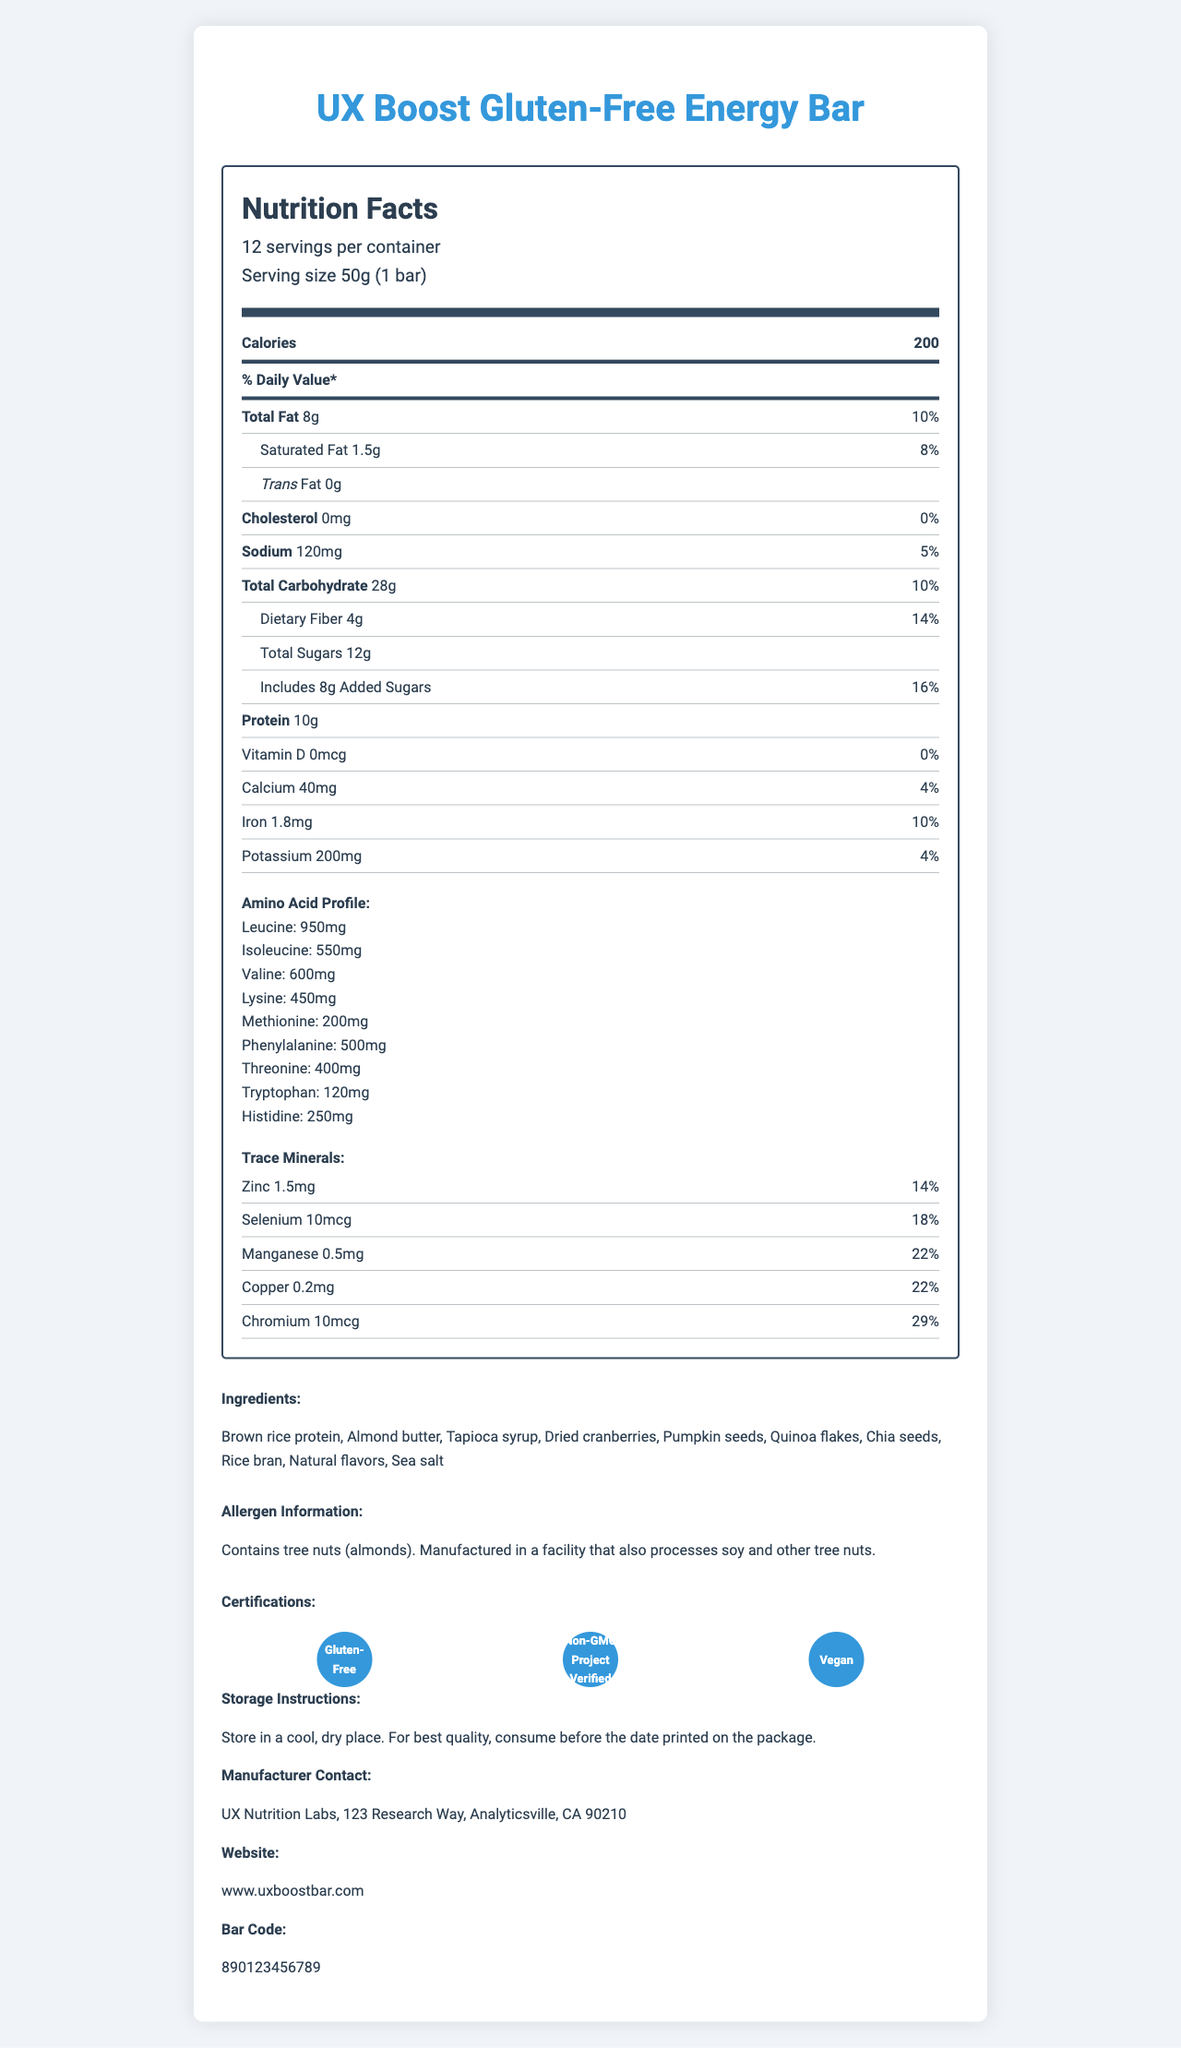what is the serving size for the "UX Boost Gluten-Free Energy Bar"? The serving size is stated as "50g (1 bar)" in the nutrition facts section.
Answer: 50g (1 bar) what is the total amount of protein in one serving? The nutrition label lists the protein content as "10g".
Answer: 10g which amino acid has the highest amount in the profile? A. Leucine B. Isoleucine C. Valine D. Lysine The amino acid profile section shows that Leucine has 950mg, which is the highest amount compared to the other amino acids.
Answer: A. Leucine is there any trans fat in this energy bar? The nutrition facts label specifies "Trans Fat 0g".
Answer: No what certifications does this product have? The certifications are listed towards the bottom of the label and include "Gluten-Free," "Non-G GMO Project Verified," and "Vegan".
Answer: Gluten-Free, Non-GMO Project Verified, Vegan how much dietary fiber does one serving contain? The nutrition facts list the dietary fiber content as 4g.
Answer: 4g which trace mineral has the highest daily value percentage? The trace minerals section indicates that Chromium has 29% daily value, which is the highest among the listed trace minerals.
Answer: Chromium does this product contain any added sugars? The nutrition facts indicate 8g of added sugars.
Answer: Yes what is the storage instruction for this product? The storage instructions are provided towards the bottom of the document.
Answer: Store in a cool, dry place. For best quality, consume before the date printed on the package. is this product suitable for vegans? The document states that the product is certified "Vegan".
Answer: Yes what is the contact address for the manufacturer? The manufacturer's contact address is specified at the bottom of the document.
Answer: UX Nutrition Labs, 123 Research Way, Analyticsville, CA 90210 what are the main ingredients in this energy bar? The ingredients are listed in a dedicated section in the document.
Answer: Brown rice protein, Almond butter, Tapioca syrup, Dried cranberries, Pumpkin seeds, Quinoa flakes, Chia seeds, Rice bran, Natural flavors, Sea salt how much calcium is in one serving? The nutrition facts label lists Calcium as 40mg.
Answer: 40mg summarize the primary information provided in this nutrition facts label. The document contains thorough details about the nutritional composition and additional certifications of the "UX Boost Gluten-Free Energy Bar," including specifics on its macronutrients, micronutrients, amino acid profile, and allergen information.
Answer: The document provides the nutritional information for the "UX Boost Gluten-Free Energy Bar," detailing serving size, calories, and macronutrients like fat, carbohydrates, and protein. It also includes an amino acid profile, trace minerals, and certain certifications. Additionally, it gives information on ingredients, allergen warnings, storage instructions, and contact information. how much sodium is in one bar? The sodium content for one bar is listed as 120mg in the nutrition facts section.
Answer: 120mg is iron one of the trace minerals listed? Despite being a mineral, iron is listed as a daily nutrient and not under the trace minerals section.
Answer: No how long is this product expected to last before it should be consumed? The document provides storage instructions but does not specify the exact expiration date, stating to consume before the date printed on the package.
Answer: Not enough information 